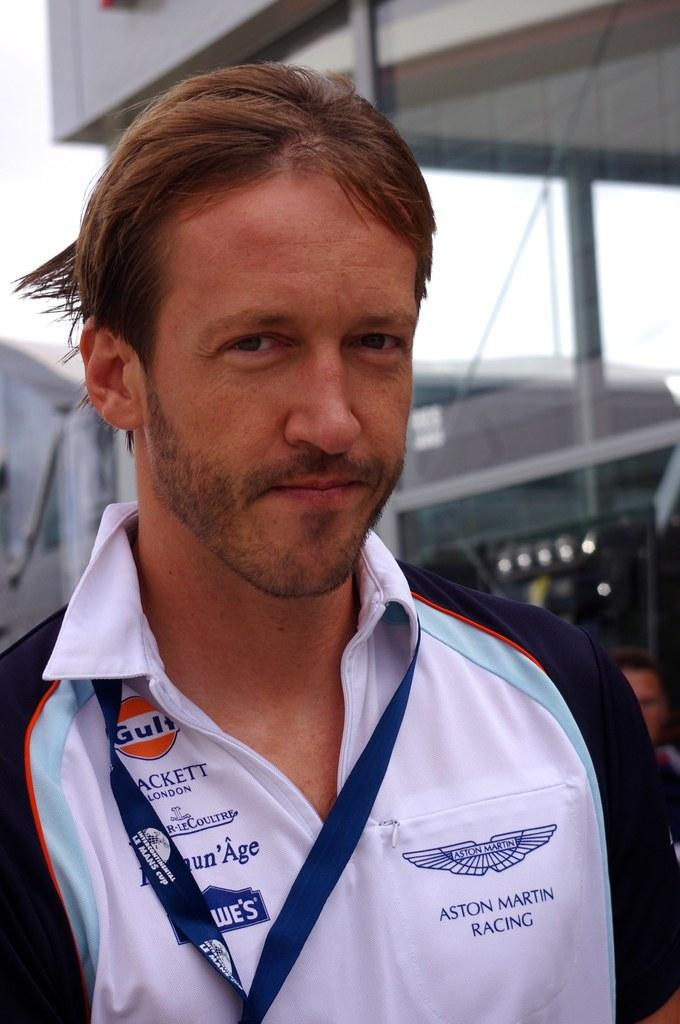<image>
Summarize the visual content of the image. Man wearing a shirt which says Aston Martin Racing. 